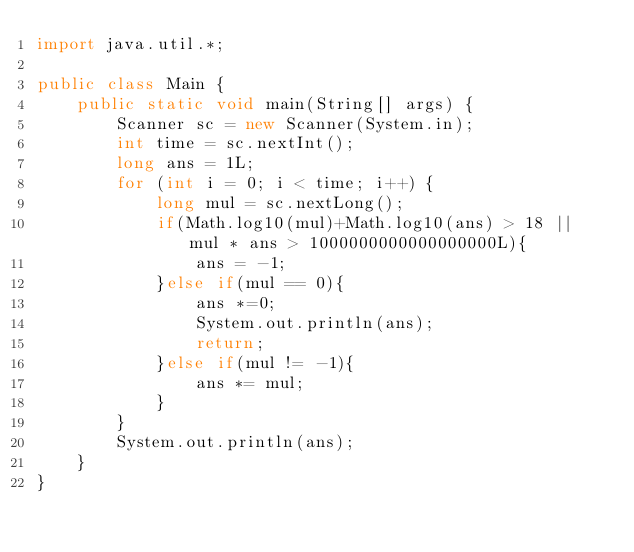Convert code to text. <code><loc_0><loc_0><loc_500><loc_500><_Java_>import java.util.*;

public class Main {
    public static void main(String[] args) {
        Scanner sc = new Scanner(System.in);
        int time = sc.nextInt();
        long ans = 1L;
        for (int i = 0; i < time; i++) {
            long mul = sc.nextLong();
            if(Math.log10(mul)+Math.log10(ans) > 18 || mul * ans > 1000000000000000000L){
                ans = -1;
            }else if(mul == 0){
                ans *=0;
                System.out.println(ans);
                return;
            }else if(mul != -1){
                ans *= mul;
            }
        }
        System.out.println(ans);
    }
}
</code> 